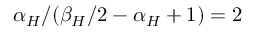<formula> <loc_0><loc_0><loc_500><loc_500>\alpha _ { H } / ( \beta _ { H } / 2 - \alpha _ { H } + 1 ) = 2</formula> 